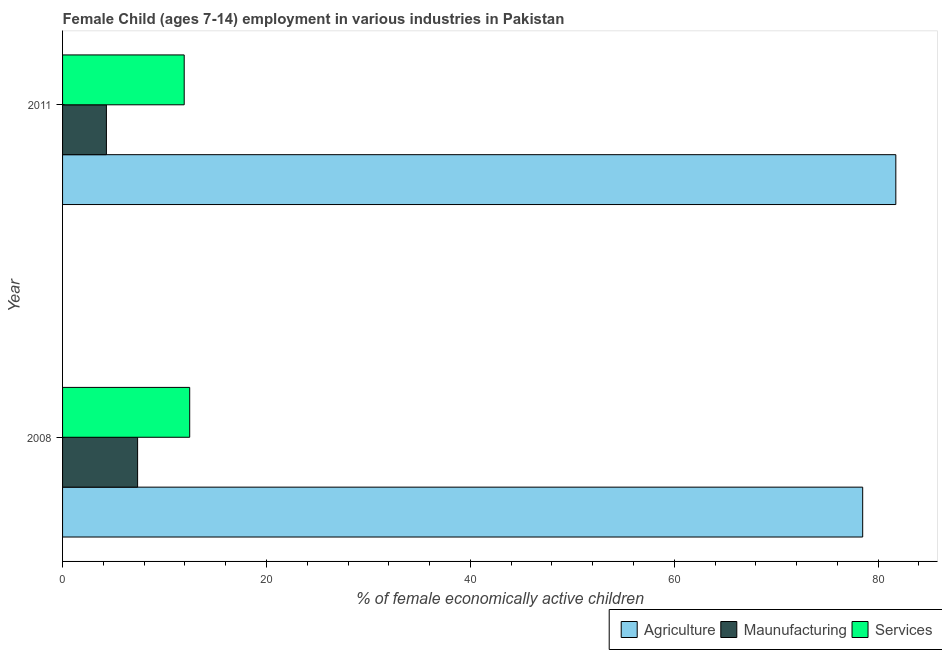How many groups of bars are there?
Your answer should be compact. 2. What is the label of the 2nd group of bars from the top?
Provide a short and direct response. 2008. In how many cases, is the number of bars for a given year not equal to the number of legend labels?
Provide a short and direct response. 0. What is the percentage of economically active children in agriculture in 2011?
Give a very brief answer. 81.73. Across all years, what is the maximum percentage of economically active children in manufacturing?
Your answer should be compact. 7.36. Across all years, what is the minimum percentage of economically active children in agriculture?
Offer a terse response. 78.48. In which year was the percentage of economically active children in services minimum?
Keep it short and to the point. 2011. What is the total percentage of economically active children in manufacturing in the graph?
Your answer should be compact. 11.66. What is the difference between the percentage of economically active children in services in 2008 and that in 2011?
Provide a short and direct response. 0.54. What is the difference between the percentage of economically active children in manufacturing in 2008 and the percentage of economically active children in services in 2011?
Ensure brevity in your answer.  -4.57. What is the average percentage of economically active children in manufacturing per year?
Provide a short and direct response. 5.83. In the year 2011, what is the difference between the percentage of economically active children in services and percentage of economically active children in agriculture?
Provide a succinct answer. -69.8. Is the percentage of economically active children in agriculture in 2008 less than that in 2011?
Provide a succinct answer. Yes. In how many years, is the percentage of economically active children in services greater than the average percentage of economically active children in services taken over all years?
Give a very brief answer. 1. What does the 3rd bar from the top in 2011 represents?
Your answer should be very brief. Agriculture. What does the 3rd bar from the bottom in 2011 represents?
Provide a succinct answer. Services. Is it the case that in every year, the sum of the percentage of economically active children in agriculture and percentage of economically active children in manufacturing is greater than the percentage of economically active children in services?
Provide a short and direct response. Yes. Are all the bars in the graph horizontal?
Offer a very short reply. Yes. What is the difference between two consecutive major ticks on the X-axis?
Your response must be concise. 20. Does the graph contain any zero values?
Ensure brevity in your answer.  No. How are the legend labels stacked?
Offer a terse response. Horizontal. What is the title of the graph?
Give a very brief answer. Female Child (ages 7-14) employment in various industries in Pakistan. What is the label or title of the X-axis?
Your answer should be very brief. % of female economically active children. What is the % of female economically active children in Agriculture in 2008?
Give a very brief answer. 78.48. What is the % of female economically active children of Maunufacturing in 2008?
Make the answer very short. 7.36. What is the % of female economically active children in Services in 2008?
Your answer should be compact. 12.47. What is the % of female economically active children of Agriculture in 2011?
Give a very brief answer. 81.73. What is the % of female economically active children of Services in 2011?
Provide a succinct answer. 11.93. Across all years, what is the maximum % of female economically active children in Agriculture?
Keep it short and to the point. 81.73. Across all years, what is the maximum % of female economically active children in Maunufacturing?
Your response must be concise. 7.36. Across all years, what is the maximum % of female economically active children of Services?
Offer a terse response. 12.47. Across all years, what is the minimum % of female economically active children in Agriculture?
Ensure brevity in your answer.  78.48. Across all years, what is the minimum % of female economically active children of Services?
Your answer should be very brief. 11.93. What is the total % of female economically active children in Agriculture in the graph?
Provide a succinct answer. 160.21. What is the total % of female economically active children of Maunufacturing in the graph?
Offer a very short reply. 11.66. What is the total % of female economically active children of Services in the graph?
Offer a terse response. 24.4. What is the difference between the % of female economically active children of Agriculture in 2008 and that in 2011?
Provide a succinct answer. -3.25. What is the difference between the % of female economically active children in Maunufacturing in 2008 and that in 2011?
Ensure brevity in your answer.  3.06. What is the difference between the % of female economically active children in Services in 2008 and that in 2011?
Keep it short and to the point. 0.54. What is the difference between the % of female economically active children of Agriculture in 2008 and the % of female economically active children of Maunufacturing in 2011?
Keep it short and to the point. 74.18. What is the difference between the % of female economically active children of Agriculture in 2008 and the % of female economically active children of Services in 2011?
Offer a terse response. 66.55. What is the difference between the % of female economically active children in Maunufacturing in 2008 and the % of female economically active children in Services in 2011?
Keep it short and to the point. -4.57. What is the average % of female economically active children of Agriculture per year?
Your response must be concise. 80.11. What is the average % of female economically active children in Maunufacturing per year?
Make the answer very short. 5.83. In the year 2008, what is the difference between the % of female economically active children of Agriculture and % of female economically active children of Maunufacturing?
Offer a terse response. 71.12. In the year 2008, what is the difference between the % of female economically active children in Agriculture and % of female economically active children in Services?
Make the answer very short. 66.01. In the year 2008, what is the difference between the % of female economically active children of Maunufacturing and % of female economically active children of Services?
Provide a succinct answer. -5.11. In the year 2011, what is the difference between the % of female economically active children of Agriculture and % of female economically active children of Maunufacturing?
Offer a very short reply. 77.43. In the year 2011, what is the difference between the % of female economically active children of Agriculture and % of female economically active children of Services?
Ensure brevity in your answer.  69.8. In the year 2011, what is the difference between the % of female economically active children in Maunufacturing and % of female economically active children in Services?
Your answer should be very brief. -7.63. What is the ratio of the % of female economically active children of Agriculture in 2008 to that in 2011?
Your response must be concise. 0.96. What is the ratio of the % of female economically active children of Maunufacturing in 2008 to that in 2011?
Provide a short and direct response. 1.71. What is the ratio of the % of female economically active children in Services in 2008 to that in 2011?
Your answer should be very brief. 1.05. What is the difference between the highest and the second highest % of female economically active children in Maunufacturing?
Your response must be concise. 3.06. What is the difference between the highest and the second highest % of female economically active children in Services?
Provide a succinct answer. 0.54. What is the difference between the highest and the lowest % of female economically active children of Agriculture?
Your answer should be compact. 3.25. What is the difference between the highest and the lowest % of female economically active children of Maunufacturing?
Ensure brevity in your answer.  3.06. What is the difference between the highest and the lowest % of female economically active children of Services?
Offer a terse response. 0.54. 